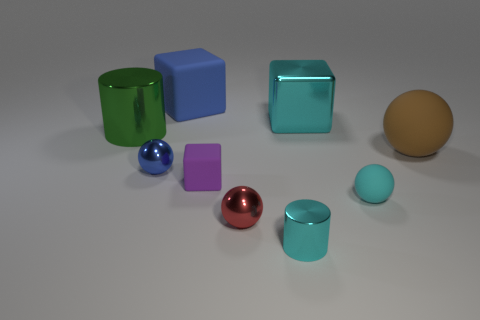The metallic cube that is the same color as the small shiny cylinder is what size?
Make the answer very short. Large. Is the color of the large shiny block the same as the shiny cylinder to the right of the tiny blue object?
Offer a very short reply. Yes. Are there the same number of small red objects behind the brown matte ball and tiny red matte objects?
Your answer should be compact. Yes. What number of red balls have the same size as the cyan metal cylinder?
Offer a terse response. 1. What is the shape of the small object that is the same color as the tiny cylinder?
Your answer should be very brief. Sphere. Is there a tiny blue metal ball?
Make the answer very short. Yes. There is a large object that is left of the tiny blue object; is it the same shape as the cyan metallic thing in front of the small purple matte object?
Provide a short and direct response. Yes. How many large objects are either brown matte things or cyan balls?
Your response must be concise. 1. There is a large brown thing that is the same material as the big blue cube; what shape is it?
Offer a terse response. Sphere. Does the green shiny object have the same shape as the brown rubber object?
Offer a terse response. No. 